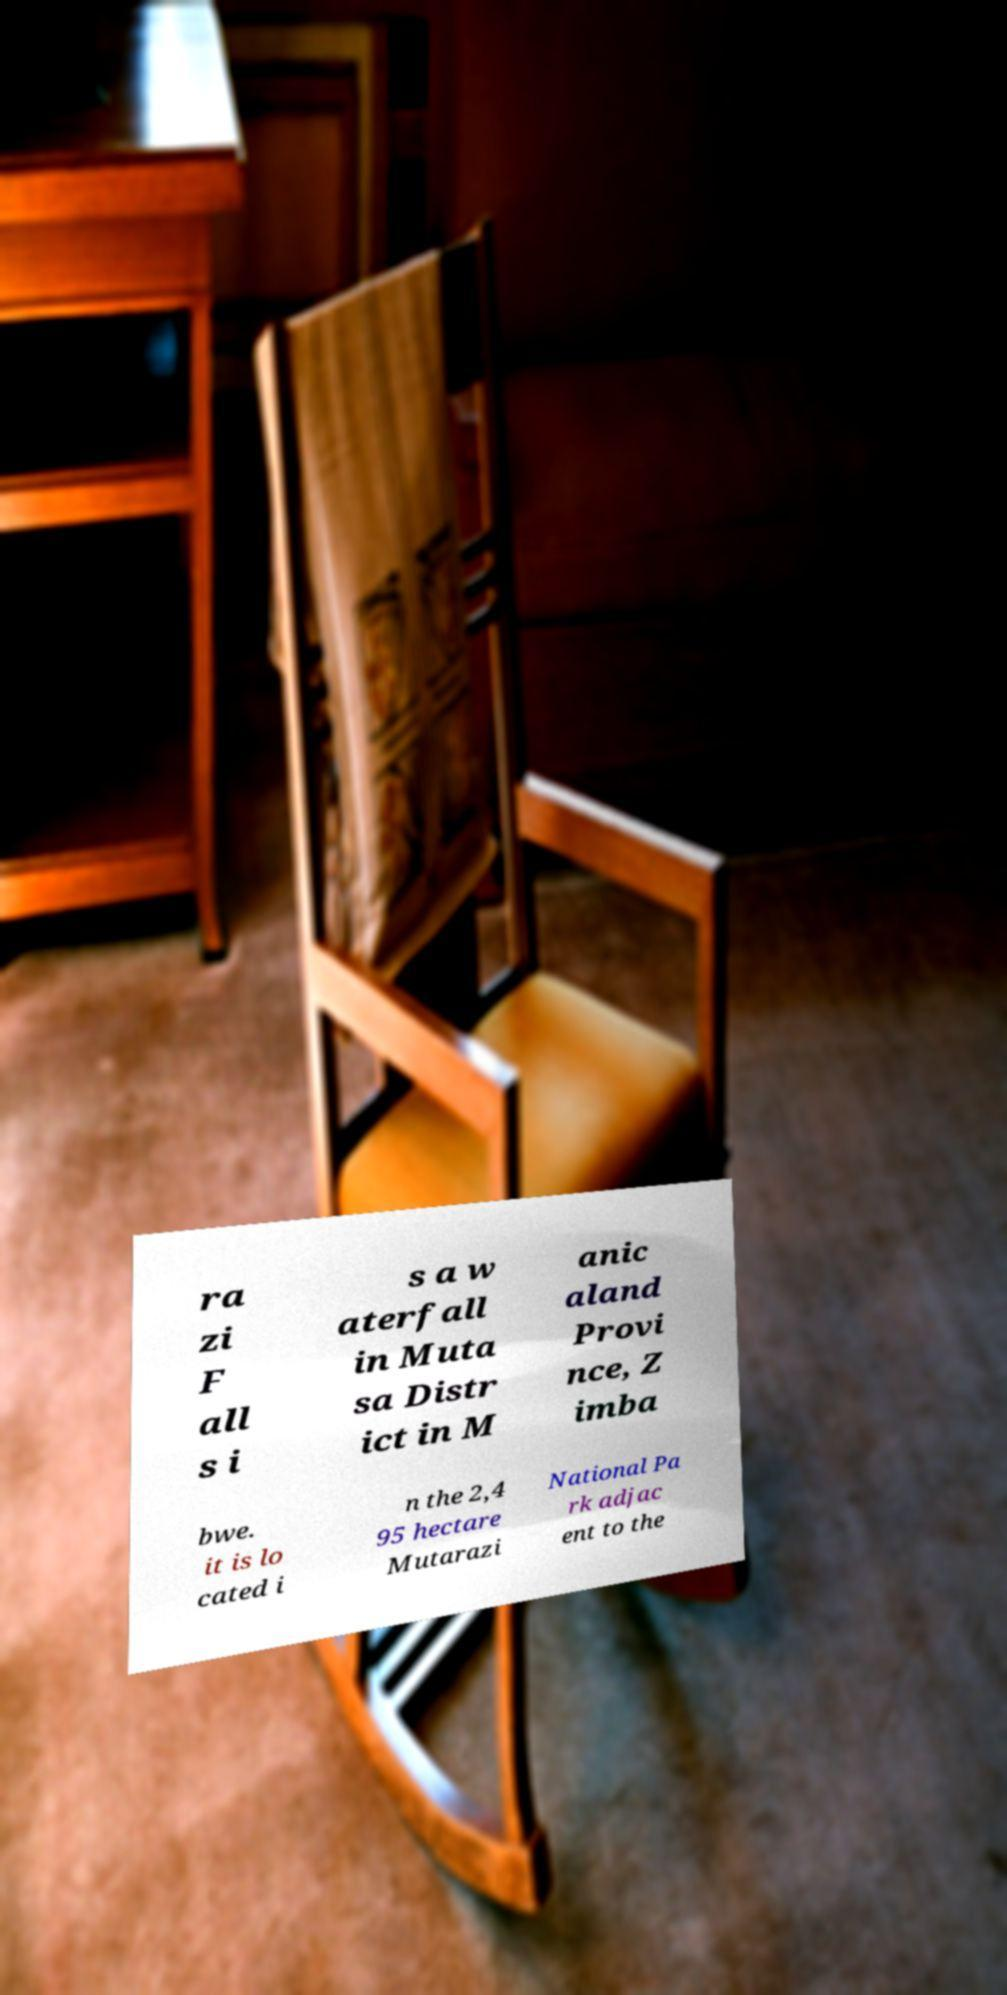Could you assist in decoding the text presented in this image and type it out clearly? ra zi F all s i s a w aterfall in Muta sa Distr ict in M anic aland Provi nce, Z imba bwe. it is lo cated i n the 2,4 95 hectare Mutarazi National Pa rk adjac ent to the 